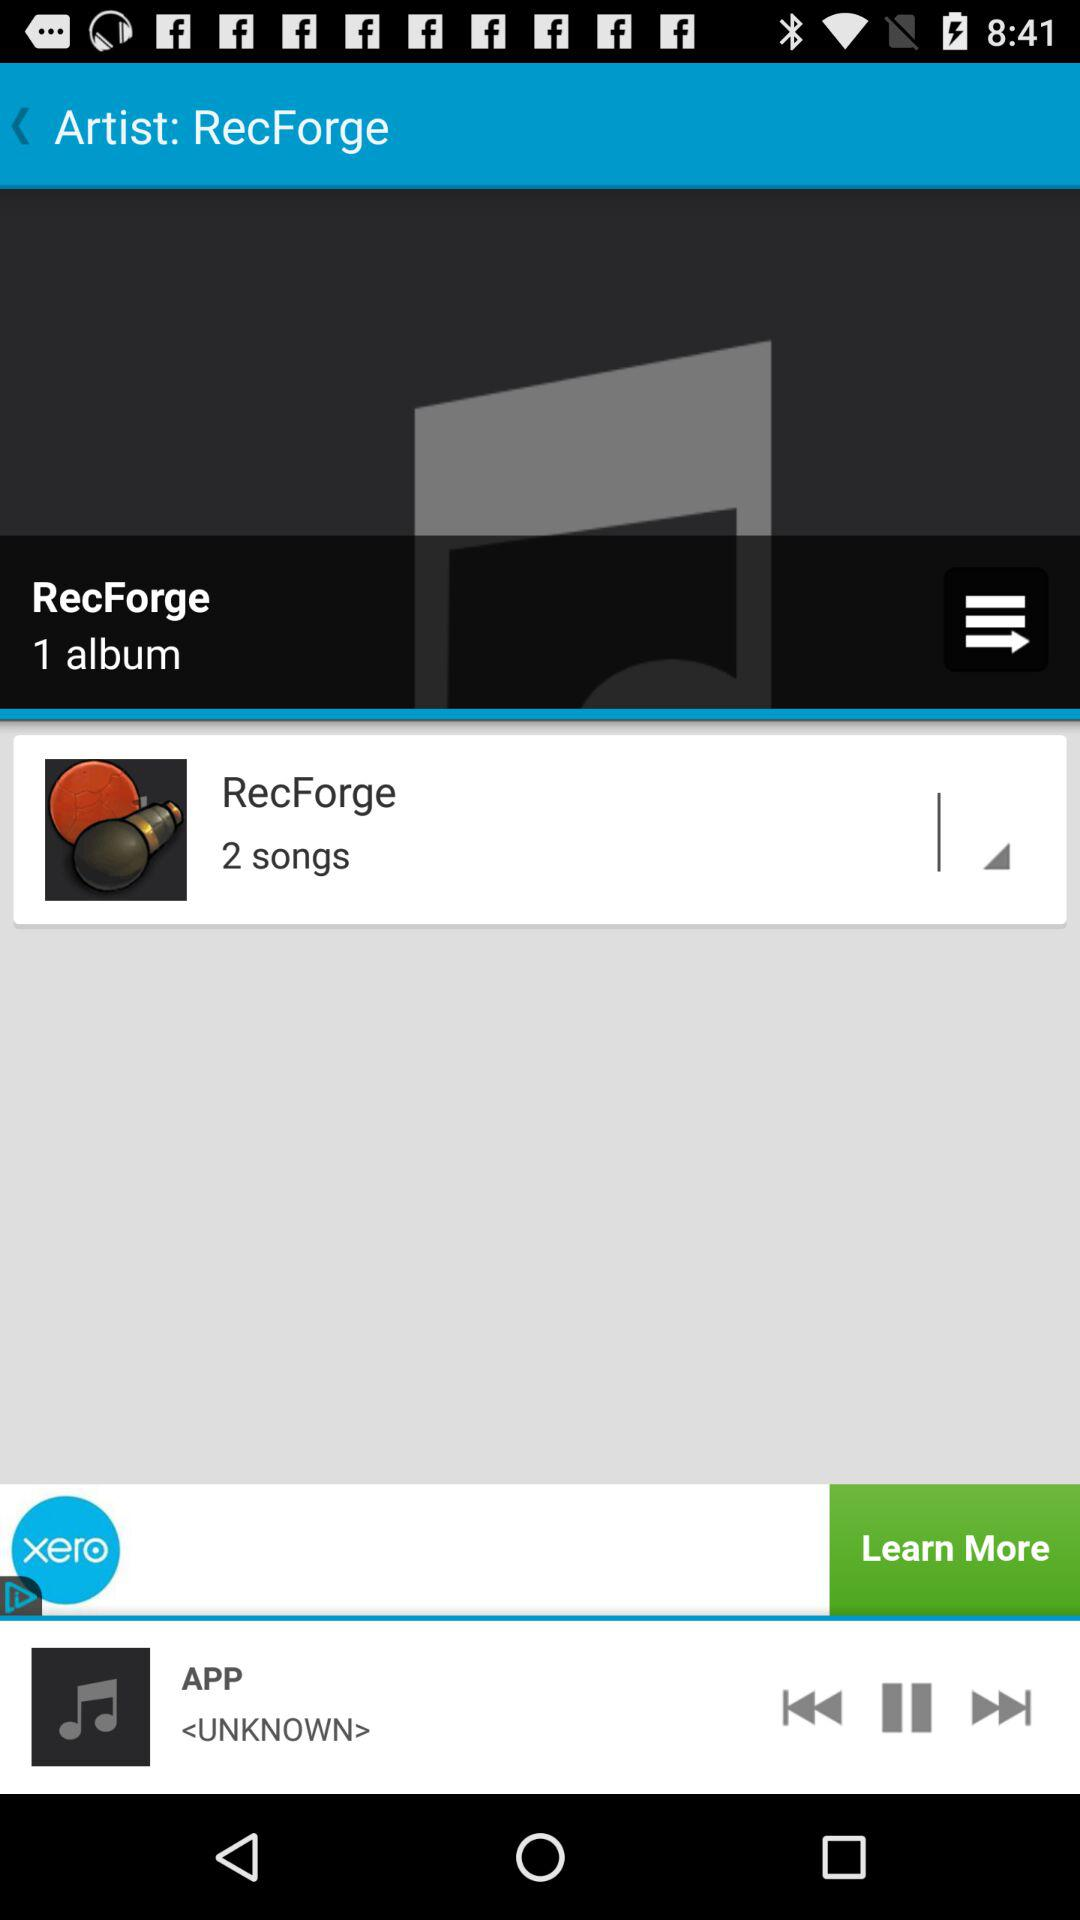How many songs are there in "RecForge"? There are 2 songs in "RecForge". 